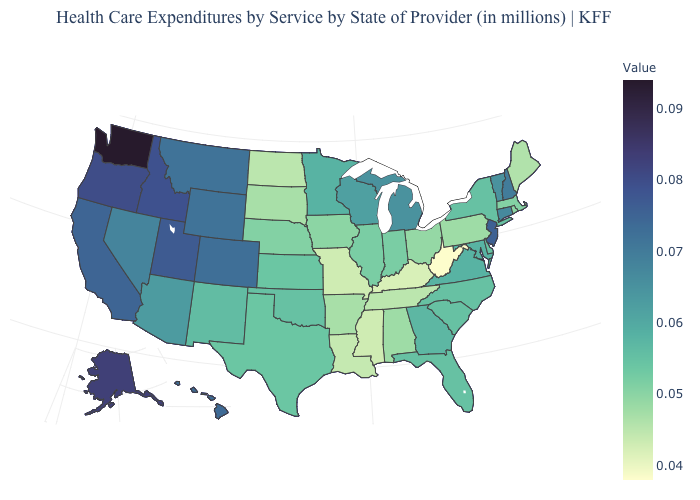Among the states that border Utah , which have the highest value?
Concise answer only. Idaho. Does Texas have the highest value in the South?
Be succinct. No. Does West Virginia have the lowest value in the USA?
Concise answer only. Yes. Which states have the lowest value in the West?
Short answer required. New Mexico. Among the states that border Tennessee , which have the highest value?
Be succinct. Virginia. 